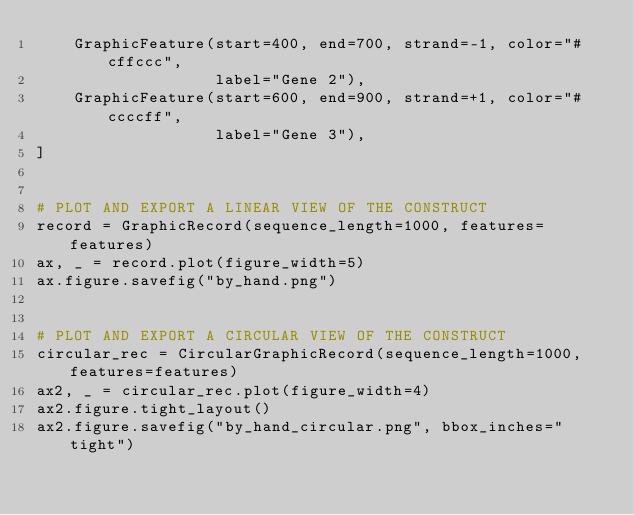Convert code to text. <code><loc_0><loc_0><loc_500><loc_500><_Python_>    GraphicFeature(start=400, end=700, strand=-1, color="#cffccc",
                   label="Gene 2"),
    GraphicFeature(start=600, end=900, strand=+1, color="#ccccff",
                   label="Gene 3"),
]


# PLOT AND EXPORT A LINEAR VIEW OF THE CONSTRUCT
record = GraphicRecord(sequence_length=1000, features=features)
ax, _ = record.plot(figure_width=5)
ax.figure.savefig("by_hand.png")


# PLOT AND EXPORT A CIRCULAR VIEW OF THE CONSTRUCT
circular_rec = CircularGraphicRecord(sequence_length=1000, features=features)
ax2, _ = circular_rec.plot(figure_width=4)
ax2.figure.tight_layout()
ax2.figure.savefig("by_hand_circular.png", bbox_inches="tight")
</code> 